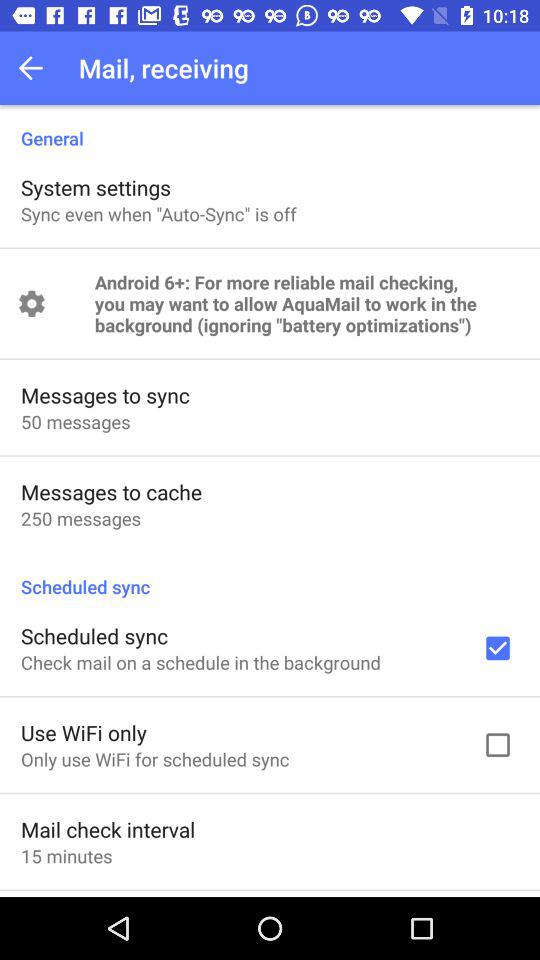What is the setting for mail check interval? The setting for mail check interval is "15 minutes". 